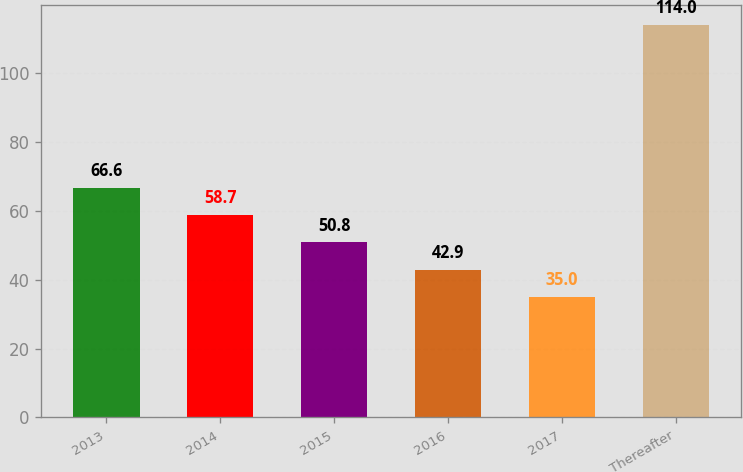Convert chart to OTSL. <chart><loc_0><loc_0><loc_500><loc_500><bar_chart><fcel>2013<fcel>2014<fcel>2015<fcel>2016<fcel>2017<fcel>Thereafter<nl><fcel>66.6<fcel>58.7<fcel>50.8<fcel>42.9<fcel>35<fcel>114<nl></chart> 